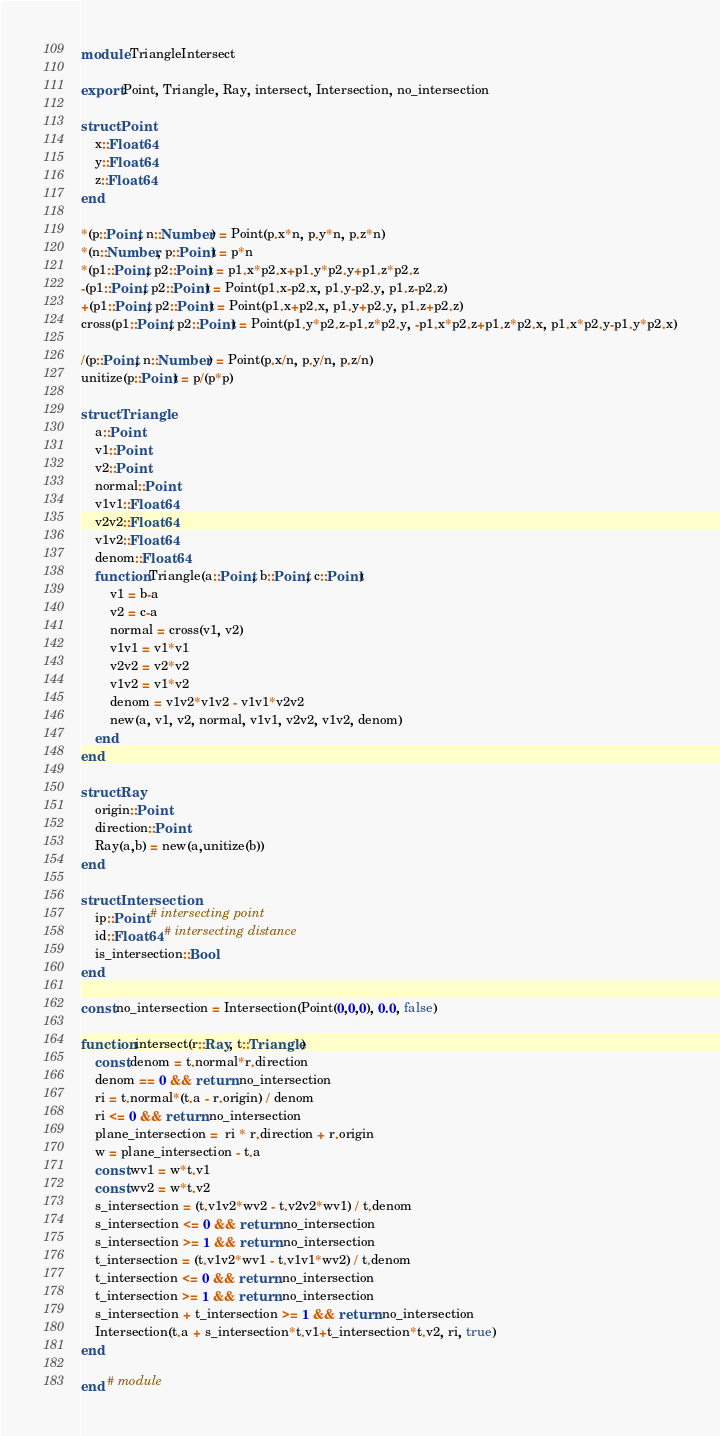<code> <loc_0><loc_0><loc_500><loc_500><_Julia_>module TriangleIntersect

export Point, Triangle, Ray, intersect, Intersection, no_intersection

struct Point
    x::Float64
    y::Float64
    z::Float64
end

*(p::Point, n::Number) = Point(p.x*n, p.y*n, p.z*n)
*(n::Number, p::Point) = p*n
*(p1::Point, p2::Point) = p1.x*p2.x+p1.y*p2.y+p1.z*p2.z
-(p1::Point, p2::Point) = Point(p1.x-p2.x, p1.y-p2.y, p1.z-p2.z)
+(p1::Point, p2::Point) = Point(p1.x+p2.x, p1.y+p2.y, p1.z+p2.z)
cross(p1::Point, p2::Point) = Point(p1.y*p2.z-p1.z*p2.y, -p1.x*p2.z+p1.z*p2.x, p1.x*p2.y-p1.y*p2.x)

/(p::Point, n::Number) = Point(p.x/n, p.y/n, p.z/n)
unitize(p::Point) = p/(p*p)

struct Triangle
    a::Point
    v1::Point
    v2::Point
    normal::Point
    v1v1::Float64
    v2v2::Float64
    v1v2::Float64
    denom::Float64
    function Triangle(a::Point, b::Point, c::Point)
        v1 = b-a
        v2 = c-a
        normal = cross(v1, v2)
        v1v1 = v1*v1
        v2v2 = v2*v2
        v1v2 = v1*v2
        denom = v1v2*v1v2 - v1v1*v2v2
        new(a, v1, v2, normal, v1v1, v2v2, v1v2, denom)
    end
end

struct Ray
    origin::Point
    direction::Point
    Ray(a,b) = new(a,unitize(b))
end

struct Intersection
    ip::Point # intersecting point
    id::Float64 # intersecting distance
    is_intersection::Bool
end

const no_intersection = Intersection(Point(0,0,0), 0.0, false)

function intersect(r::Ray, t::Triangle)
    const denom = t.normal*r.direction
    denom == 0 && return no_intersection
    ri = t.normal*(t.a - r.origin) / denom
    ri <= 0 && return no_intersection
    plane_intersection =  ri * r.direction + r.origin
    w = plane_intersection - t.a
    const wv1 = w*t.v1
    const wv2 = w*t.v2
    s_intersection = (t.v1v2*wv2 - t.v2v2*wv1) / t.denom
    s_intersection <= 0 && return no_intersection
    s_intersection >= 1 && return no_intersection
    t_intersection = (t.v1v2*wv1 - t.v1v1*wv2) / t.denom
    t_intersection <= 0 && return no_intersection
    t_intersection >= 1 && return no_intersection
    s_intersection + t_intersection >= 1 && return no_intersection
    Intersection(t.a + s_intersection*t.v1+t_intersection*t.v2, ri, true)
end

end # module
</code> 